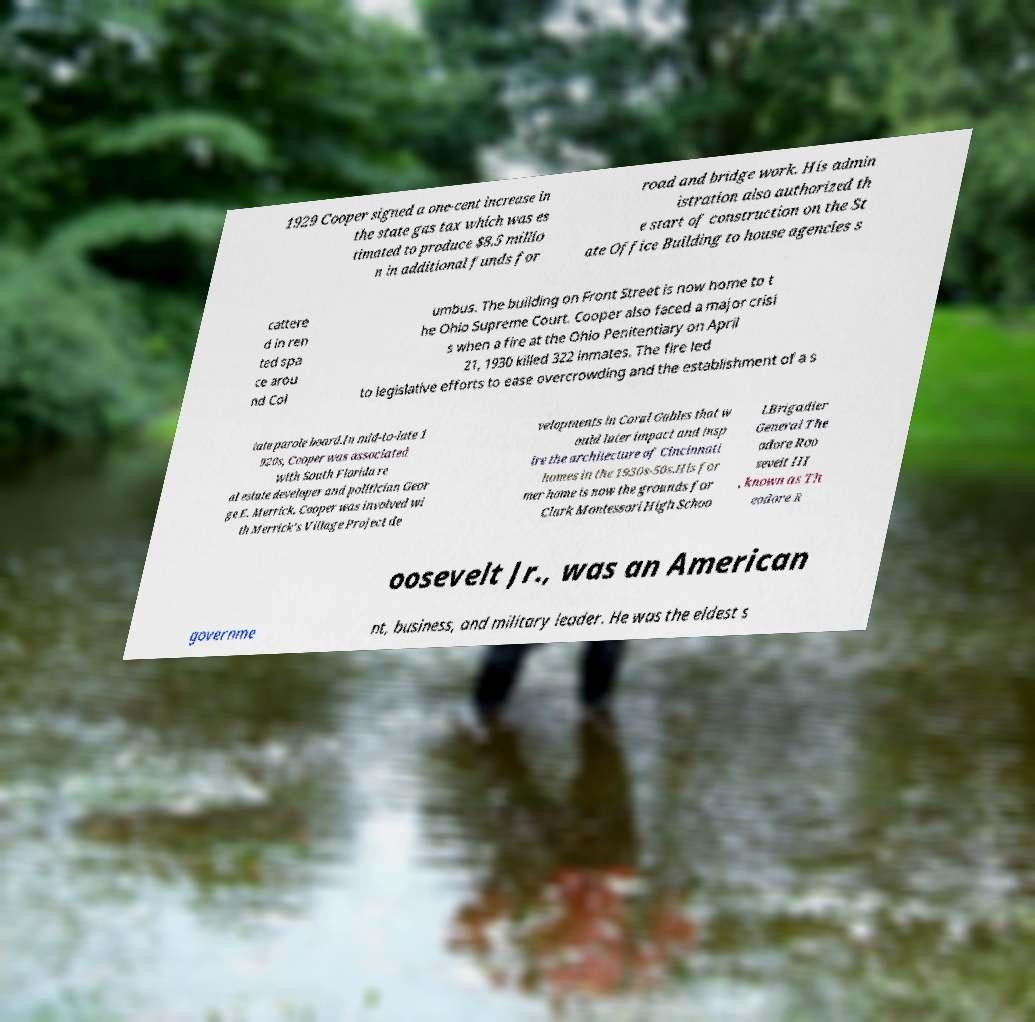What messages or text are displayed in this image? I need them in a readable, typed format. 1929 Cooper signed a one-cent increase in the state gas tax which was es timated to produce $8.5 millio n in additional funds for road and bridge work. His admin istration also authorized th e start of construction on the St ate Office Building to house agencies s cattere d in ren ted spa ce arou nd Col umbus. The building on Front Street is now home to t he Ohio Supreme Court. Cooper also faced a major crisi s when a fire at the Ohio Penitentiary on April 21, 1930 killed 322 inmates. The fire led to legislative efforts to ease overcrowding and the establishment of a s tate parole board.In mid-to-late 1 920s, Cooper was associated with South Florida re al estate developer and politician Geor ge E. Merrick. Cooper was involved wi th Merrick's Village Project de velopments in Coral Gables that w ould later impact and insp ire the architecture of Cincinnati homes in the 1930s-50s.His for mer home is now the grounds for Clark Montessori High Schoo l.Brigadier General The odore Roo sevelt III , known as Th eodore R oosevelt Jr., was an American governme nt, business, and military leader. He was the eldest s 